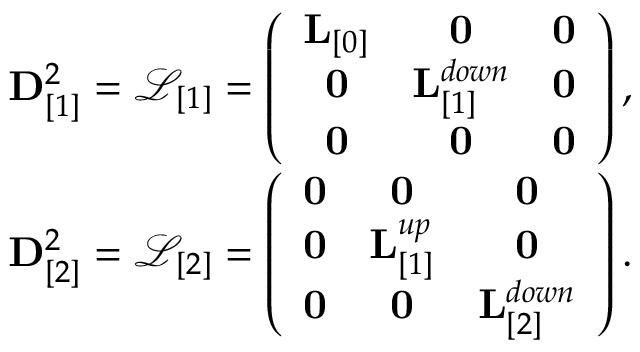<formula> <loc_0><loc_0><loc_500><loc_500>\begin{array} { r } { { D } _ { [ 1 ] } ^ { 2 } = \mathcal { L } _ { [ 1 ] } = \left ( \begin{array} { c c c } { { L } _ { [ 0 ] } } & { 0 } & { 0 } \\ { 0 } & { { L } _ { [ 1 ] } ^ { d o w n } } & { 0 } \\ { 0 } & { 0 } & { 0 } \end{array} \right ) , } \\ { { D } _ { [ 2 ] } ^ { 2 } = \mathcal { L } _ { [ 2 ] } = \left ( \begin{array} { c c c } { 0 } & { 0 } & { 0 } \\ { 0 } & { { L } _ { [ 1 ] } ^ { u p } } & { 0 } \\ { 0 } & { 0 } & { { L } _ { [ 2 ] } ^ { d o w n } } \end{array} \right ) . } \end{array}</formula> 